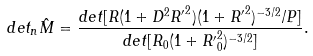Convert formula to latex. <formula><loc_0><loc_0><loc_500><loc_500>d e t _ { n } { \hat { M } } = \frac { d e t [ R ( 1 + D ^ { 2 } { R ^ { \prime } } ^ { 2 } ) ( 1 + { R ^ { \prime } } ^ { 2 } ) ^ { - 3 / 2 } / P ] } { d e t [ R _ { 0 } ( 1 + { R ^ { \prime } } ^ { 2 } _ { 0 } ) ^ { - 3 / 2 } ] } .</formula> 